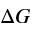<formula> <loc_0><loc_0><loc_500><loc_500>\Delta G</formula> 